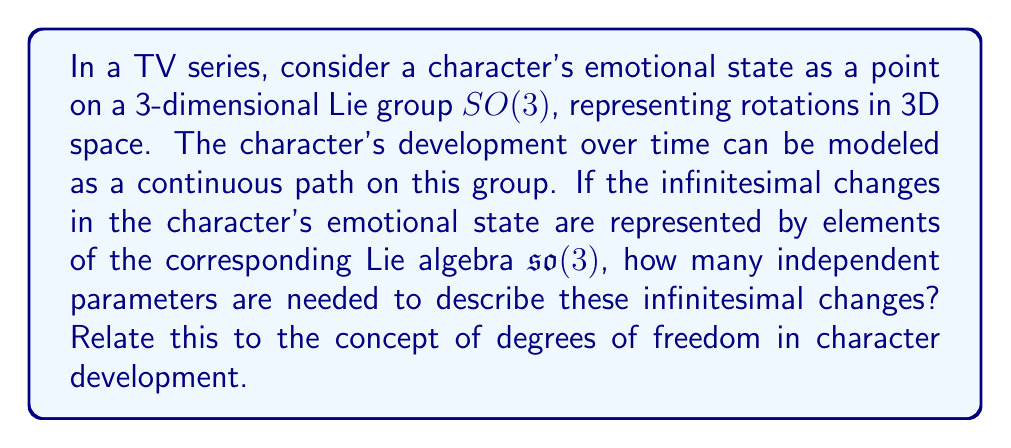Teach me how to tackle this problem. To solve this problem, we need to understand the relationship between the Lie group $SO(3)$ and its corresponding Lie algebra $\mathfrak{so}(3)$.

1) The Lie group $SO(3)$ represents all rotations in 3D space. It is a 3-dimensional manifold, meaning that any element of $SO(3)$ can be described by 3 parameters (e.g., Euler angles).

2) The Lie algebra $\mathfrak{so}(3)$ is the tangent space at the identity element of $SO(3)$. It consists of all possible infinitesimal rotations.

3) Elements of $\mathfrak{so}(3)$ are 3x3 skew-symmetric matrices of the form:

   $$
   \begin{pmatrix}
   0 & -\omega_3 & \omega_2 \\
   \omega_3 & 0 & -\omega_1 \\
   -\omega_2 & \omega_1 & 0
   \end{pmatrix}
   $$

4) The parameters $\omega_1$, $\omega_2$, and $\omega_3$ represent infinitesimal rotations around the x, y, and z axes respectively.

5) Therefore, any element of $\mathfrak{so}(3)$ can be uniquely described by 3 independent parameters.

In the context of character development:
- The 3 dimensions of $SO(3)$ could represent different aspects of a character's emotional state (e.g., happiness, anger, fear).
- The 3 parameters of $\mathfrak{so}(3)$ represent the rates of change in these emotional dimensions.
- This means that at any given moment, the character's emotional development can be described by 3 degrees of freedom, corresponding to how quickly they're changing in each emotional dimension.
Answer: The number of independent parameters needed to describe infinitesimal changes in the character's emotional state is 3, corresponding to the 3 degrees of freedom in character development as represented by the Lie algebra $\mathfrak{so}(3)$. 